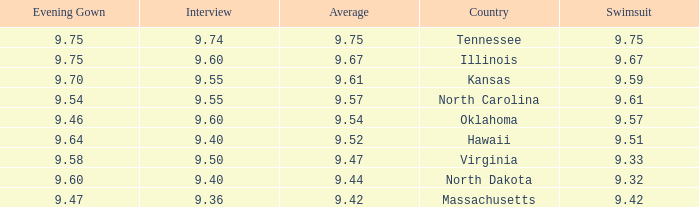What was the interview score for Hawaii? 9.4. 